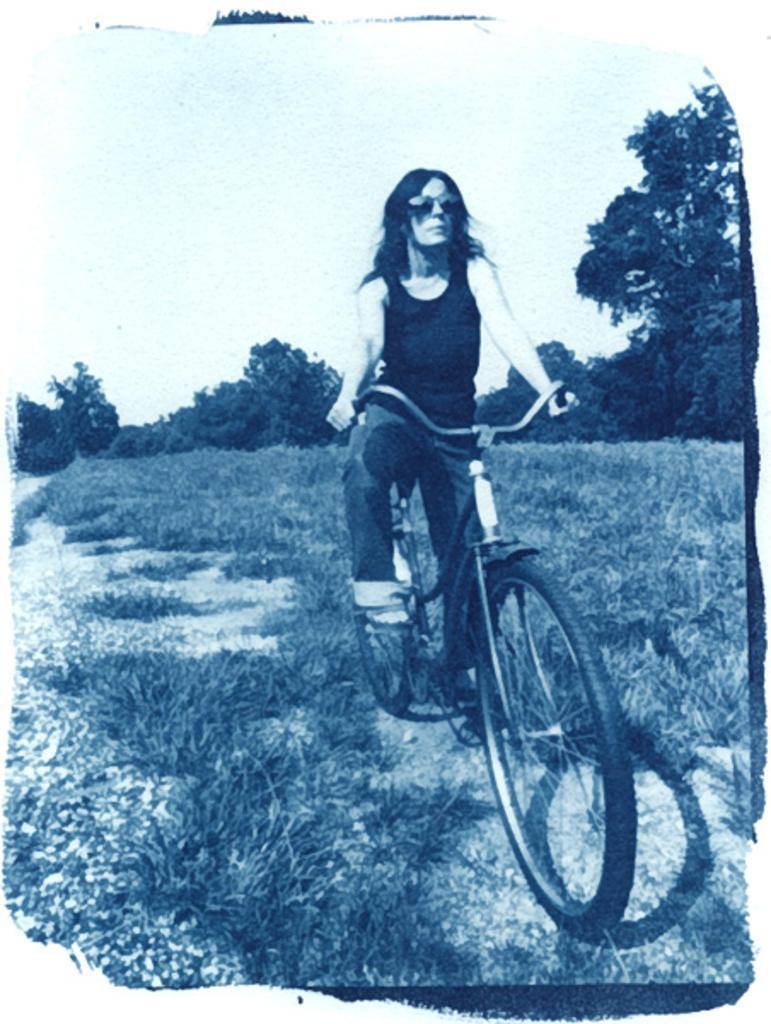In one or two sentences, can you explain what this image depicts? In this picture, In the middle there is a woman riding a bicycle and in the background there are some green color trees and sky in white color. 